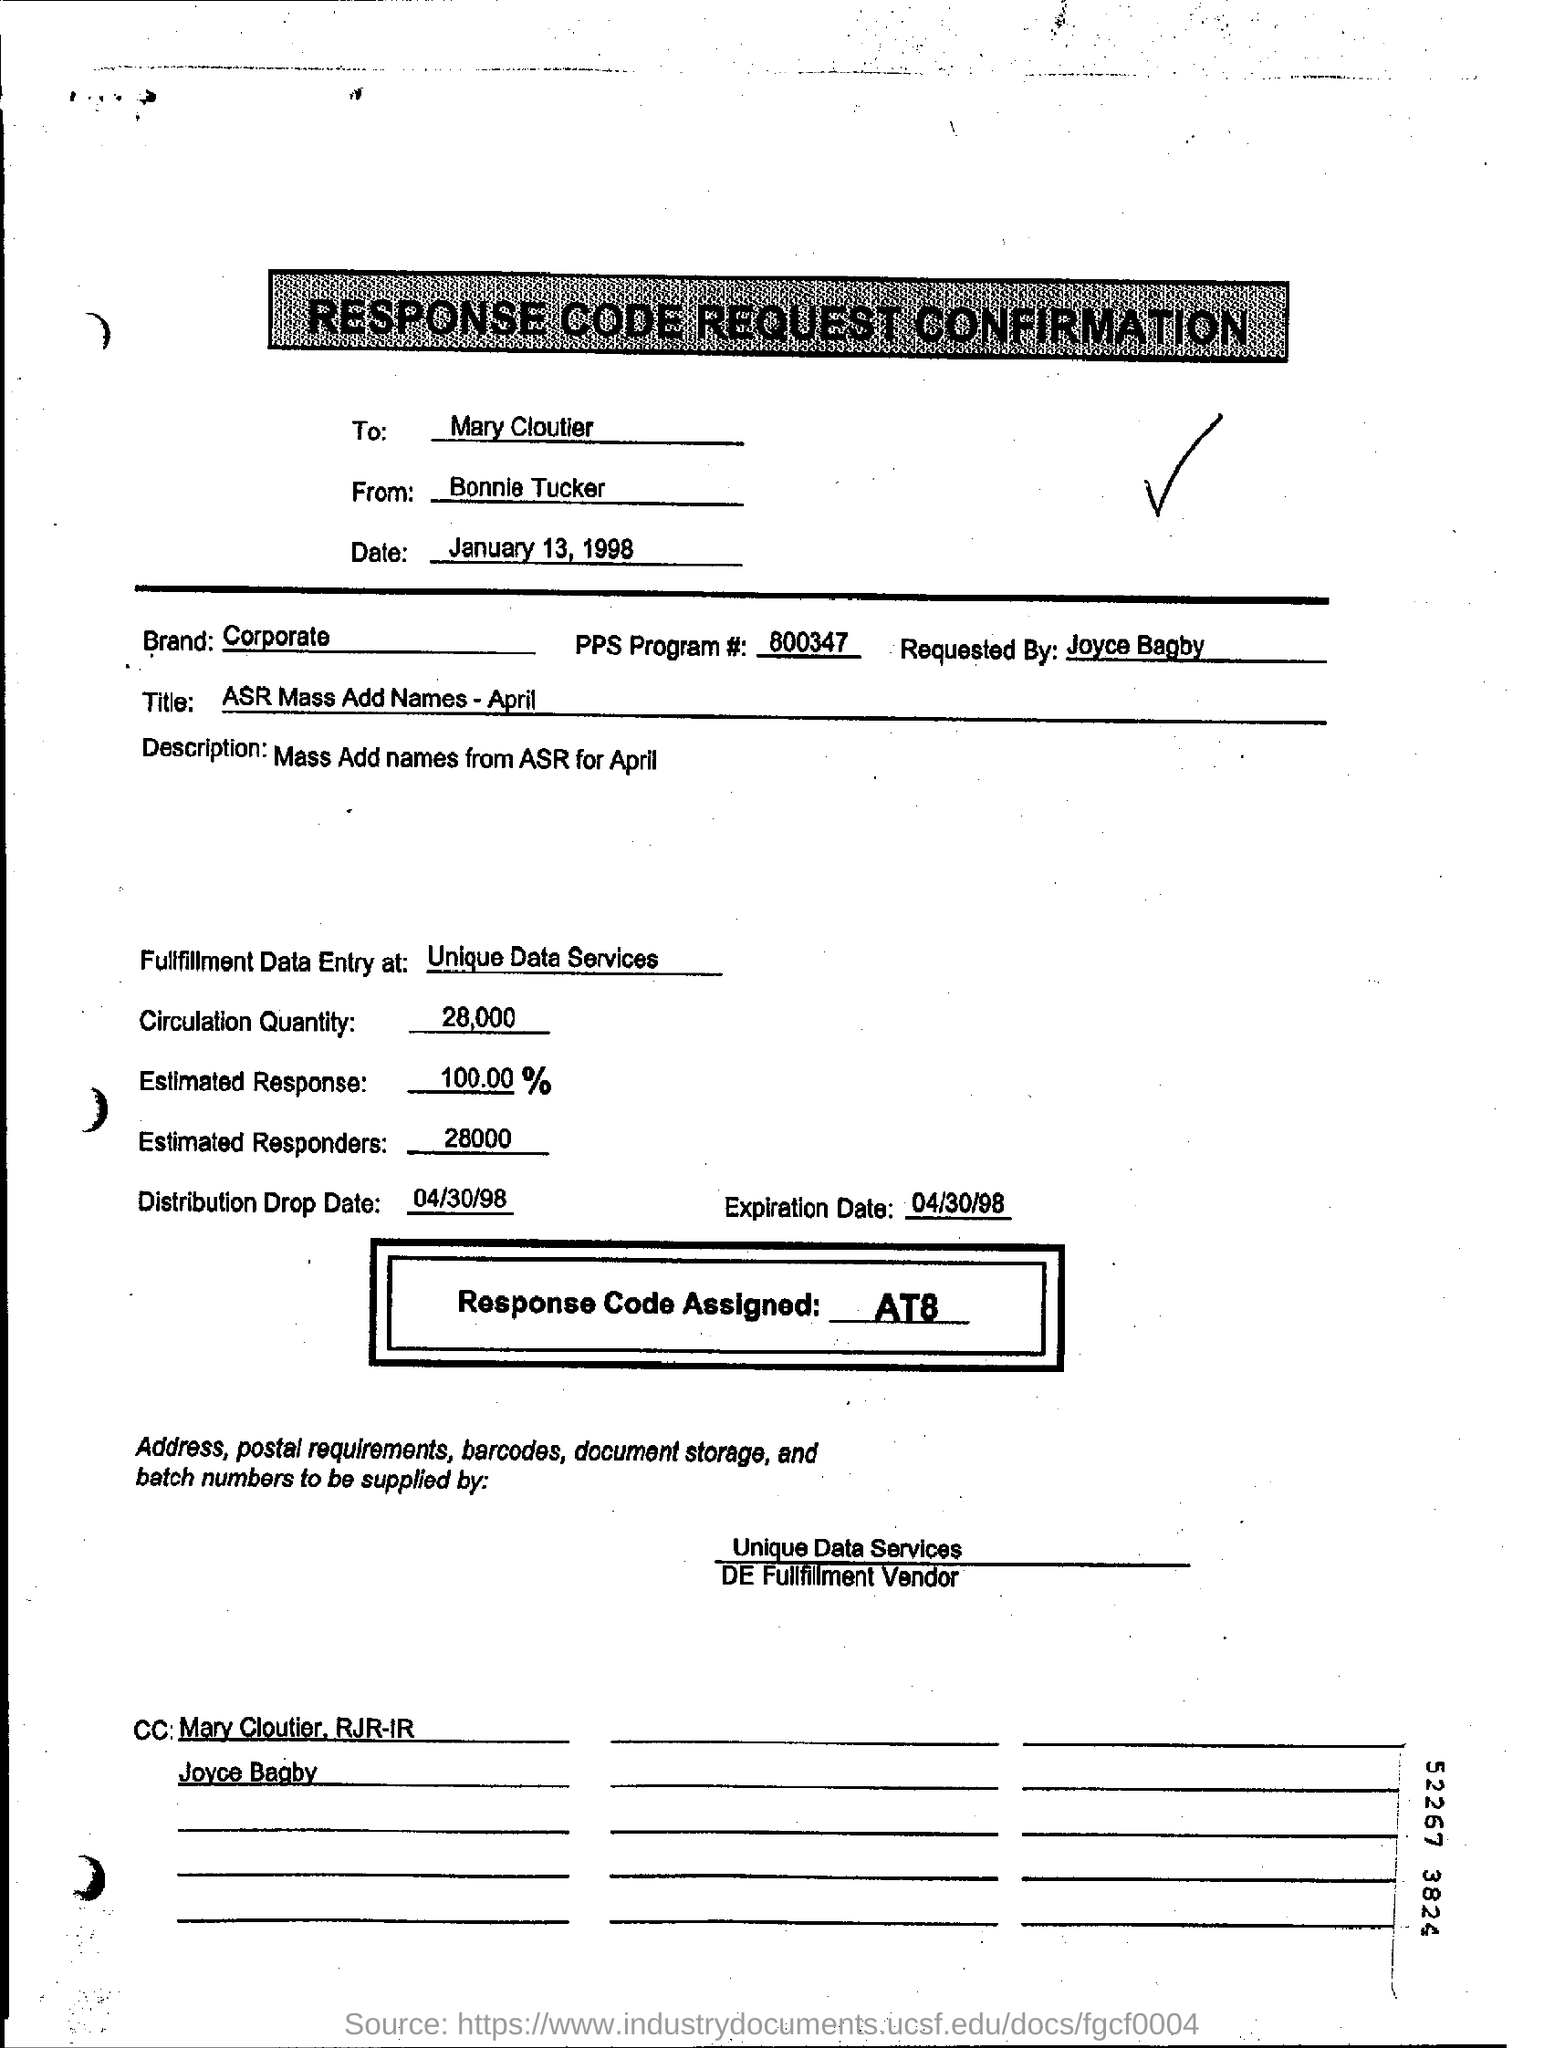What is the number of pps program#?
Give a very brief answer. 800347. What is in the title ?
Provide a short and direct response. ASR Mass Add Names - April. When response code request for confirmation is dated on ?
Provide a short and direct response. January 13, 1998. What is the  expiration date ?
Provide a short and direct response. 04/30/98. What is "distribution drop date"?
Make the answer very short. 04/30/98. What is the number of estimated responders?
Offer a very short reply. 28000. 